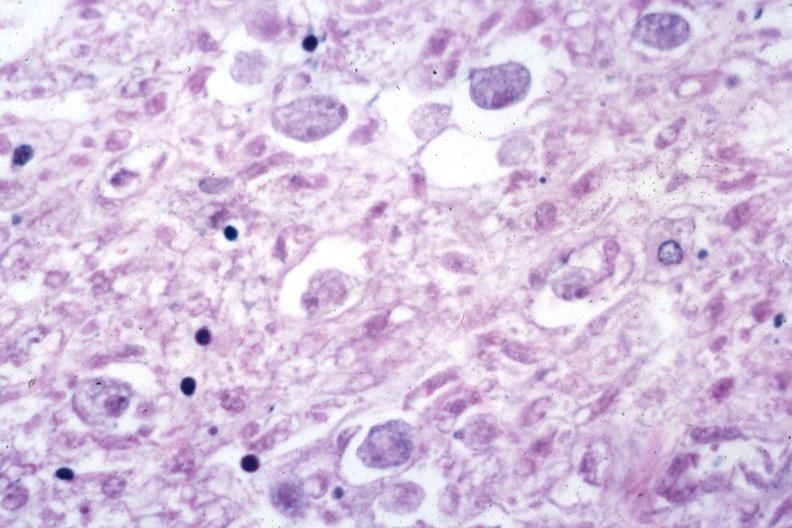what is present?
Answer the question using a single word or phrase. Amebiasis 